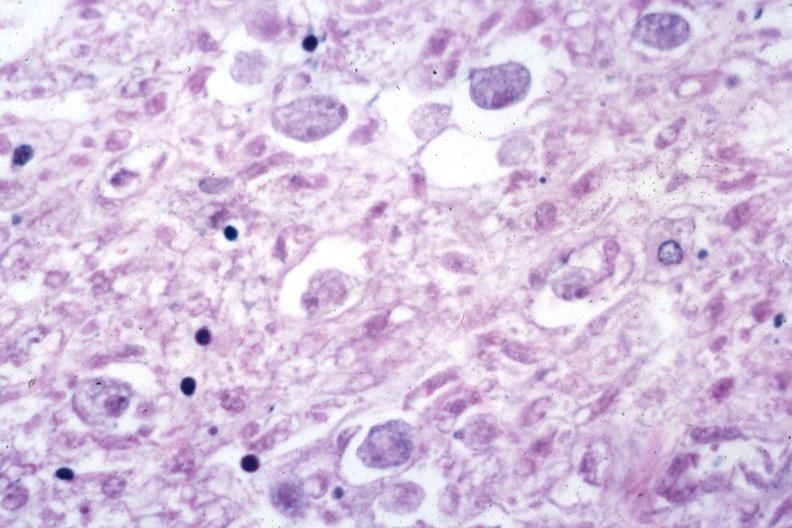what is present?
Answer the question using a single word or phrase. Amebiasis 